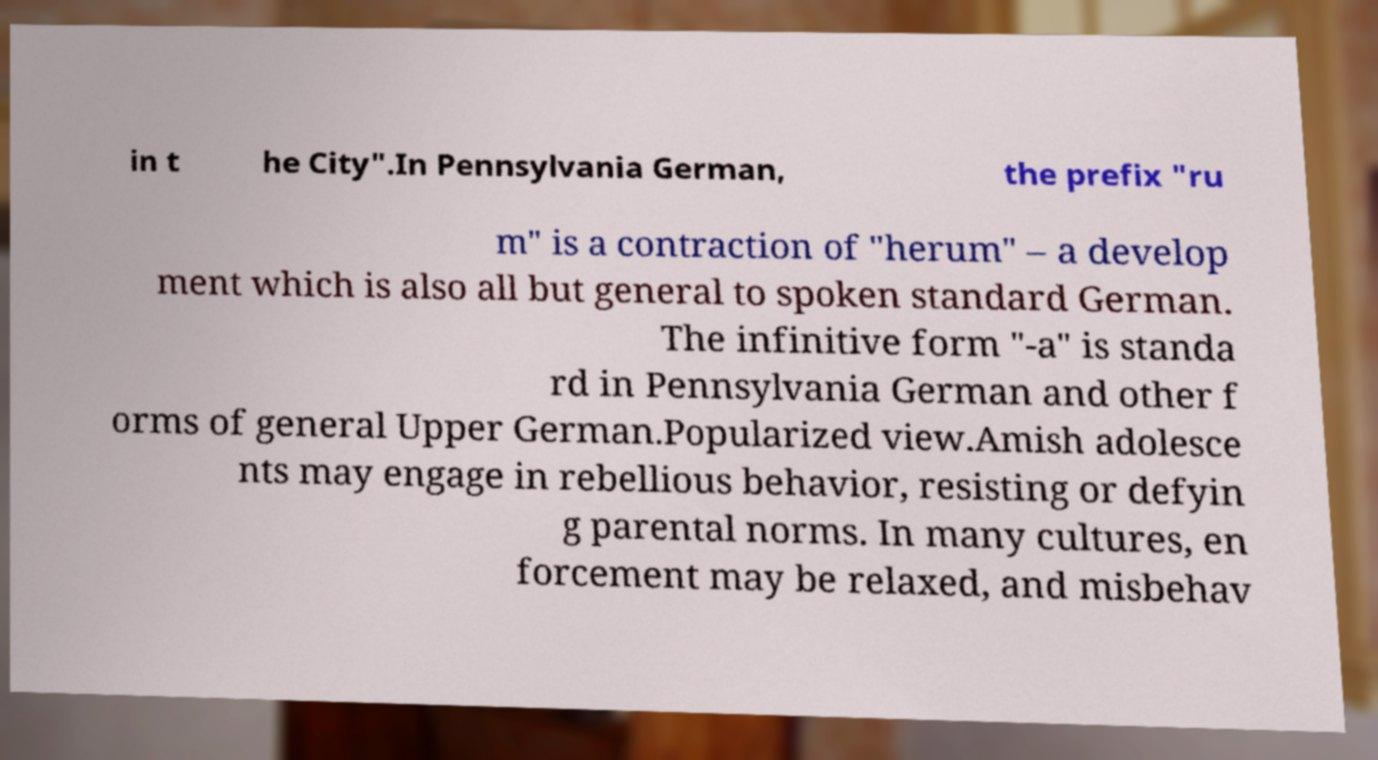Can you accurately transcribe the text from the provided image for me? in t he City".In Pennsylvania German, the prefix "ru m" is a contraction of "herum" – a develop ment which is also all but general to spoken standard German. The infinitive form "-a" is standa rd in Pennsylvania German and other f orms of general Upper German.Popularized view.Amish adolesce nts may engage in rebellious behavior, resisting or defyin g parental norms. In many cultures, en forcement may be relaxed, and misbehav 